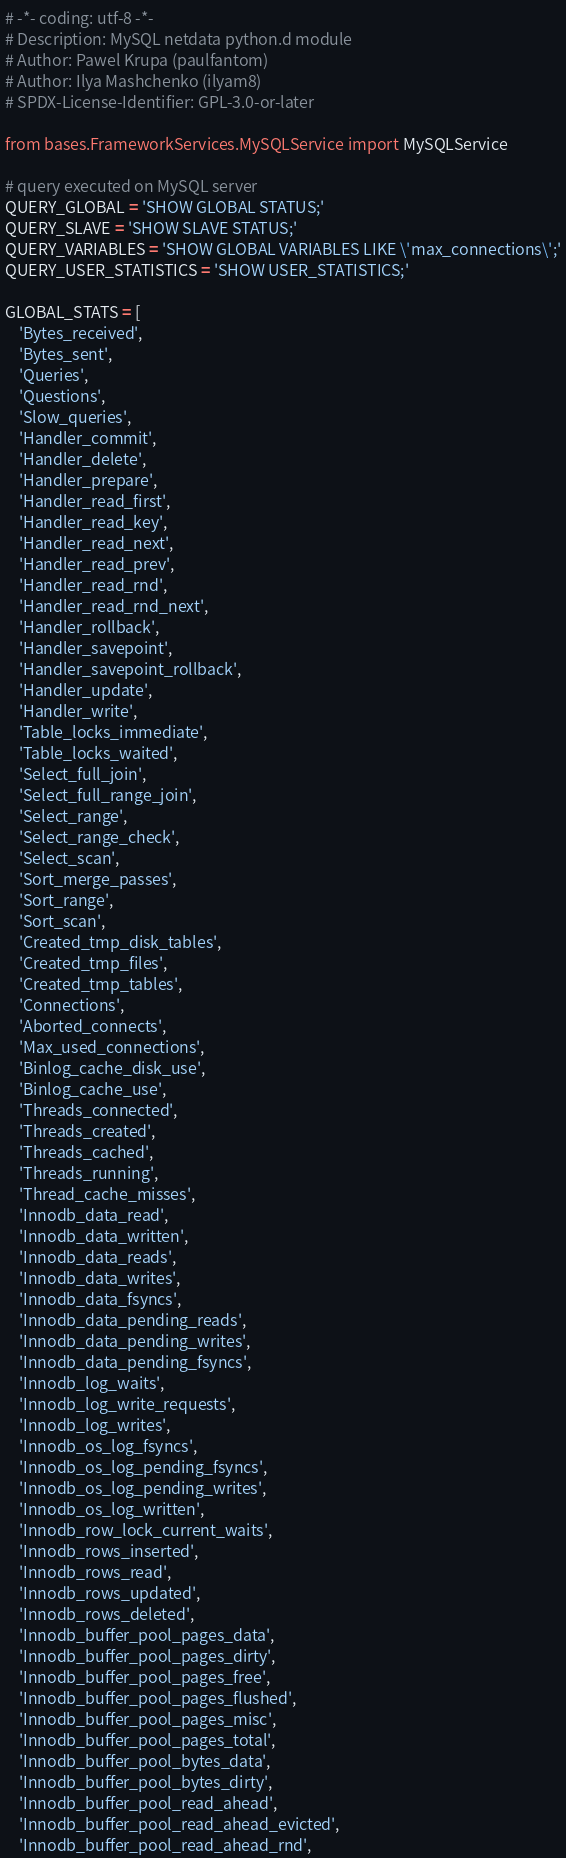<code> <loc_0><loc_0><loc_500><loc_500><_Python_># -*- coding: utf-8 -*-
# Description: MySQL netdata python.d module
# Author: Pawel Krupa (paulfantom)
# Author: Ilya Mashchenko (ilyam8)
# SPDX-License-Identifier: GPL-3.0-or-later

from bases.FrameworkServices.MySQLService import MySQLService

# query executed on MySQL server
QUERY_GLOBAL = 'SHOW GLOBAL STATUS;'
QUERY_SLAVE = 'SHOW SLAVE STATUS;'
QUERY_VARIABLES = 'SHOW GLOBAL VARIABLES LIKE \'max_connections\';'
QUERY_USER_STATISTICS = 'SHOW USER_STATISTICS;'

GLOBAL_STATS = [
    'Bytes_received',
    'Bytes_sent',
    'Queries',
    'Questions',
    'Slow_queries',
    'Handler_commit',
    'Handler_delete',
    'Handler_prepare',
    'Handler_read_first',
    'Handler_read_key',
    'Handler_read_next',
    'Handler_read_prev',
    'Handler_read_rnd',
    'Handler_read_rnd_next',
    'Handler_rollback',
    'Handler_savepoint',
    'Handler_savepoint_rollback',
    'Handler_update',
    'Handler_write',
    'Table_locks_immediate',
    'Table_locks_waited',
    'Select_full_join',
    'Select_full_range_join',
    'Select_range',
    'Select_range_check',
    'Select_scan',
    'Sort_merge_passes',
    'Sort_range',
    'Sort_scan',
    'Created_tmp_disk_tables',
    'Created_tmp_files',
    'Created_tmp_tables',
    'Connections',
    'Aborted_connects',
    'Max_used_connections',
    'Binlog_cache_disk_use',
    'Binlog_cache_use',
    'Threads_connected',
    'Threads_created',
    'Threads_cached',
    'Threads_running',
    'Thread_cache_misses',
    'Innodb_data_read',
    'Innodb_data_written',
    'Innodb_data_reads',
    'Innodb_data_writes',
    'Innodb_data_fsyncs',
    'Innodb_data_pending_reads',
    'Innodb_data_pending_writes',
    'Innodb_data_pending_fsyncs',
    'Innodb_log_waits',
    'Innodb_log_write_requests',
    'Innodb_log_writes',
    'Innodb_os_log_fsyncs',
    'Innodb_os_log_pending_fsyncs',
    'Innodb_os_log_pending_writes',
    'Innodb_os_log_written',
    'Innodb_row_lock_current_waits',
    'Innodb_rows_inserted',
    'Innodb_rows_read',
    'Innodb_rows_updated',
    'Innodb_rows_deleted',
    'Innodb_buffer_pool_pages_data',
    'Innodb_buffer_pool_pages_dirty',
    'Innodb_buffer_pool_pages_free',
    'Innodb_buffer_pool_pages_flushed',
    'Innodb_buffer_pool_pages_misc',
    'Innodb_buffer_pool_pages_total',
    'Innodb_buffer_pool_bytes_data',
    'Innodb_buffer_pool_bytes_dirty',
    'Innodb_buffer_pool_read_ahead',
    'Innodb_buffer_pool_read_ahead_evicted',
    'Innodb_buffer_pool_read_ahead_rnd',</code> 